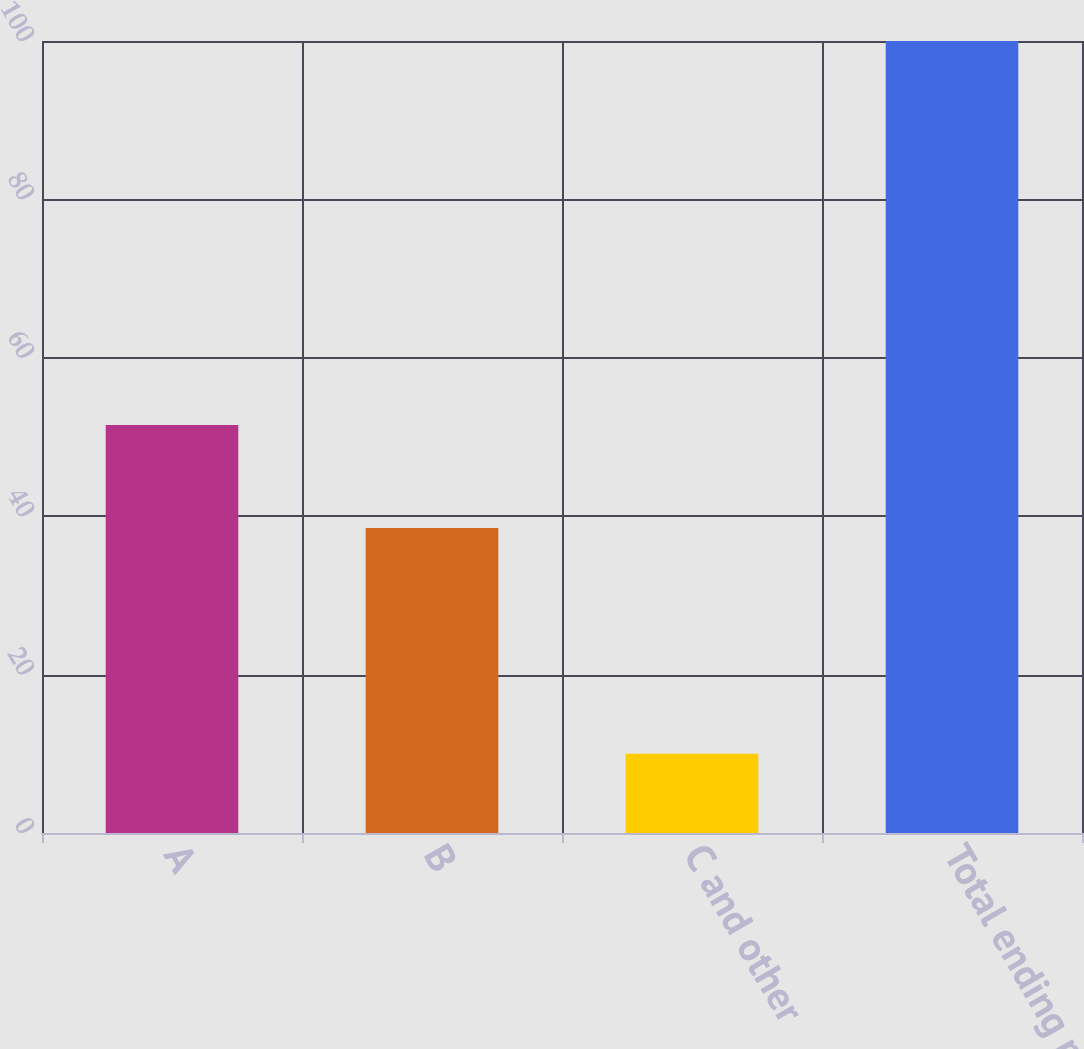Convert chart. <chart><loc_0><loc_0><loc_500><loc_500><bar_chart><fcel>A<fcel>B<fcel>C and other<fcel>Total ending managed<nl><fcel>51.5<fcel>38.5<fcel>10<fcel>100<nl></chart> 